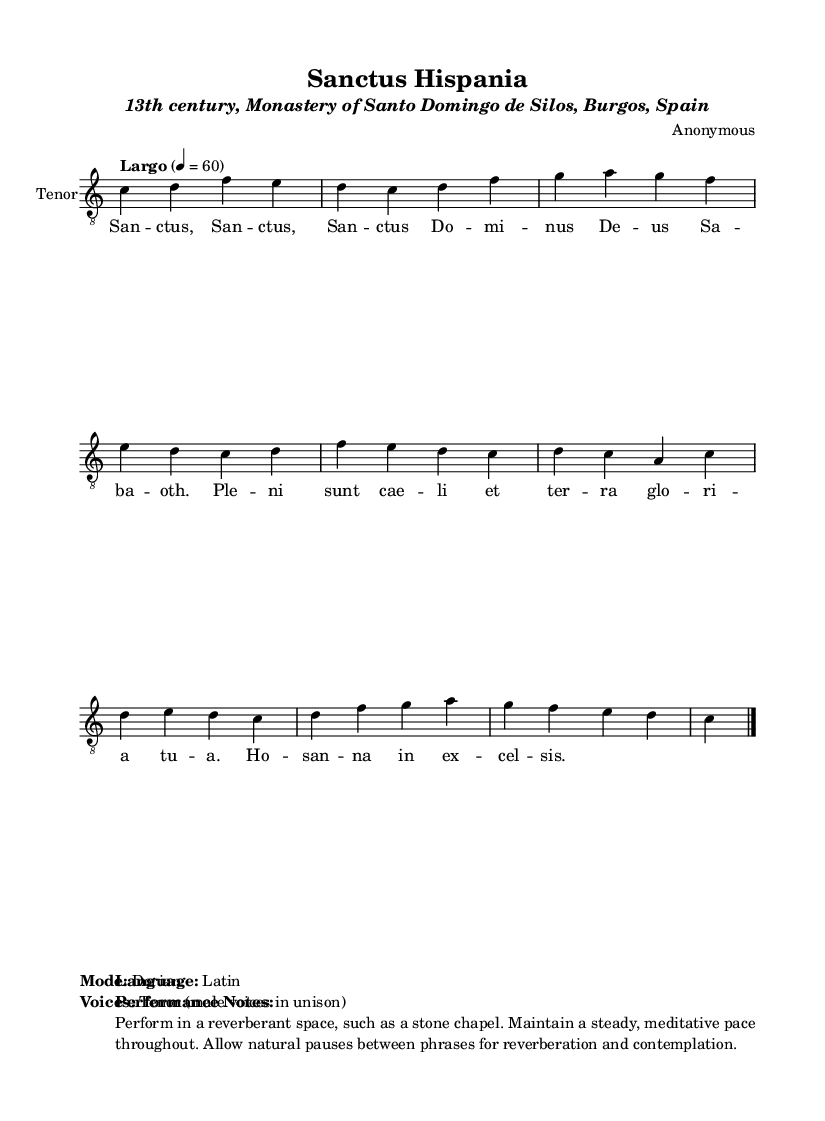What is the key signature of this music? The key signature is C major, which has no sharps or flats.
Answer: C major What is the time signature of this piece? The time signature is indicated as 4/4, meaning there are four beats per measure, and the quarter note gets one beat.
Answer: 4/4 What is the tempo marking for this chant? The tempo marking indicates "Largo," which signifies a slow pace. The specific speed is set at a quarter note equaling 60 BPM.
Answer: Largo What is the mode used in this Gregorian chant? The mode is indicated as Dorian, which is a type of medieval church mode characterized by a specific interval pattern.
Answer: Dorian How many times is the word "Sanctus" repeated in the lyrics? The word "Sanctus" is repeated three times in the lyrics as shown in the notation.
Answer: Three What type of voices are indicated for the performance? The performance is for male voices in unison, as specified in the markup section of the sheet music.
Answer: Tenor (male voices in unison) What language are the lyrics of this chant written in? The lyrics are written in Latin, which is typical for religious Gregorian chants.
Answer: Latin 